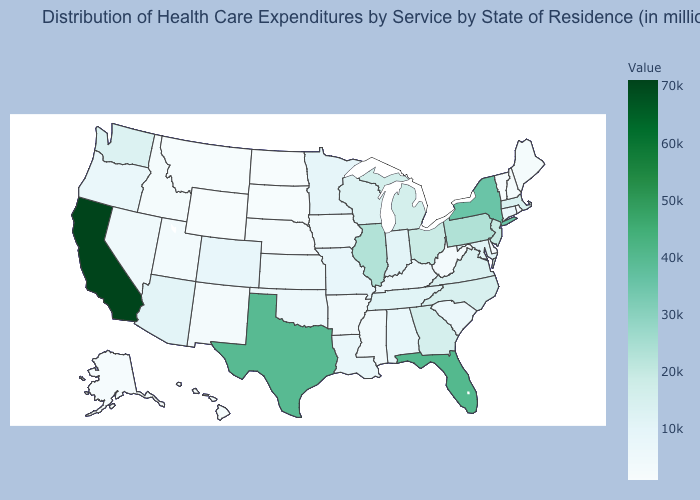Does Wyoming have the lowest value in the USA?
Keep it brief. Yes. Which states have the highest value in the USA?
Be succinct. California. Which states have the lowest value in the West?
Concise answer only. Wyoming. Which states have the highest value in the USA?
Give a very brief answer. California. Does the map have missing data?
Short answer required. No. 